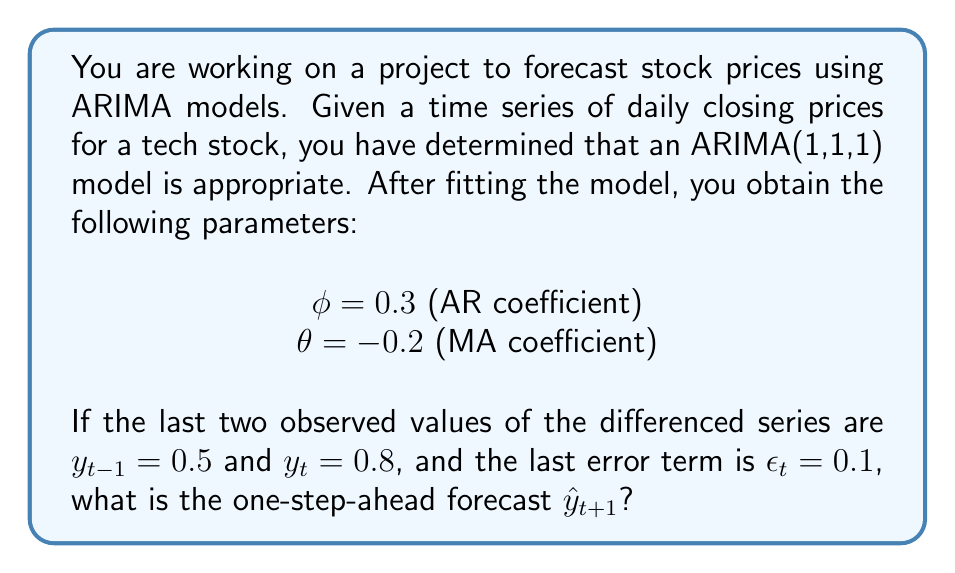Can you answer this question? To solve this problem, we need to follow these steps:

1. Recall the ARIMA(1,1,1) model equation:
   $$(1-B)(1-\phi B)Y_t = (1-\theta B)\epsilon_t$$
   where $B$ is the backshift operator.

2. Expand this equation:
   $$Y_t - Y_{t-1} - \phi Y_{t-1} + \phi Y_{t-2} = \epsilon_t - \theta \epsilon_{t-1}$$

3. Rearrange to isolate $Y_t$:
   $$Y_t = Y_{t-1} + \phi Y_{t-1} - \phi Y_{t-2} + \epsilon_t - \theta \epsilon_{t-1}$$

4. For forecasting, we replace future error terms with their expected value (0) and future observations with their forecasts. So, our forecast equation becomes:
   $$\hat{Y}_{t+1} = Y_t + \phi(Y_t - Y_{t-1}) - \theta \epsilon_t$$

5. We are given the differenced series values, so we need to convert back to the original series:
   $y_t = Y_t - Y_{t-1}$
   $Y_t = Y_{t-1} + y_t$
   $Y_{t-1} = Y_{t-2} + y_{t-1}$

6. Substitute these into our forecast equation:
   $$\hat{Y}_{t+1} = (Y_{t-1} + y_t) + \phi y_t - \theta \epsilon_t$$

7. Now, let's plug in our values:
   $\phi = 0.3$
   $\theta = -0.2$
   $y_t = 0.8$
   $\epsilon_t = 0.1$

8. Calculate the forecast:
   $$\hat{Y}_{t+1} = (Y_{t-1} + 0.8) + 0.3(0.8) - (-0.2)(0.1)$$
   $$\hat{Y}_{t+1} = Y_{t-1} + 0.8 + 0.24 + 0.02$$
   $$\hat{Y}_{t+1} = Y_{t-1} + 1.06$$

9. The forecast is expressed in terms of $Y_{t-1}$, which represents the last observed value of the original (non-differenced) series. This is the one-step-ahead forecast.
Answer: $\hat{Y}_{t+1} = Y_{t-1} + 1.06$ 